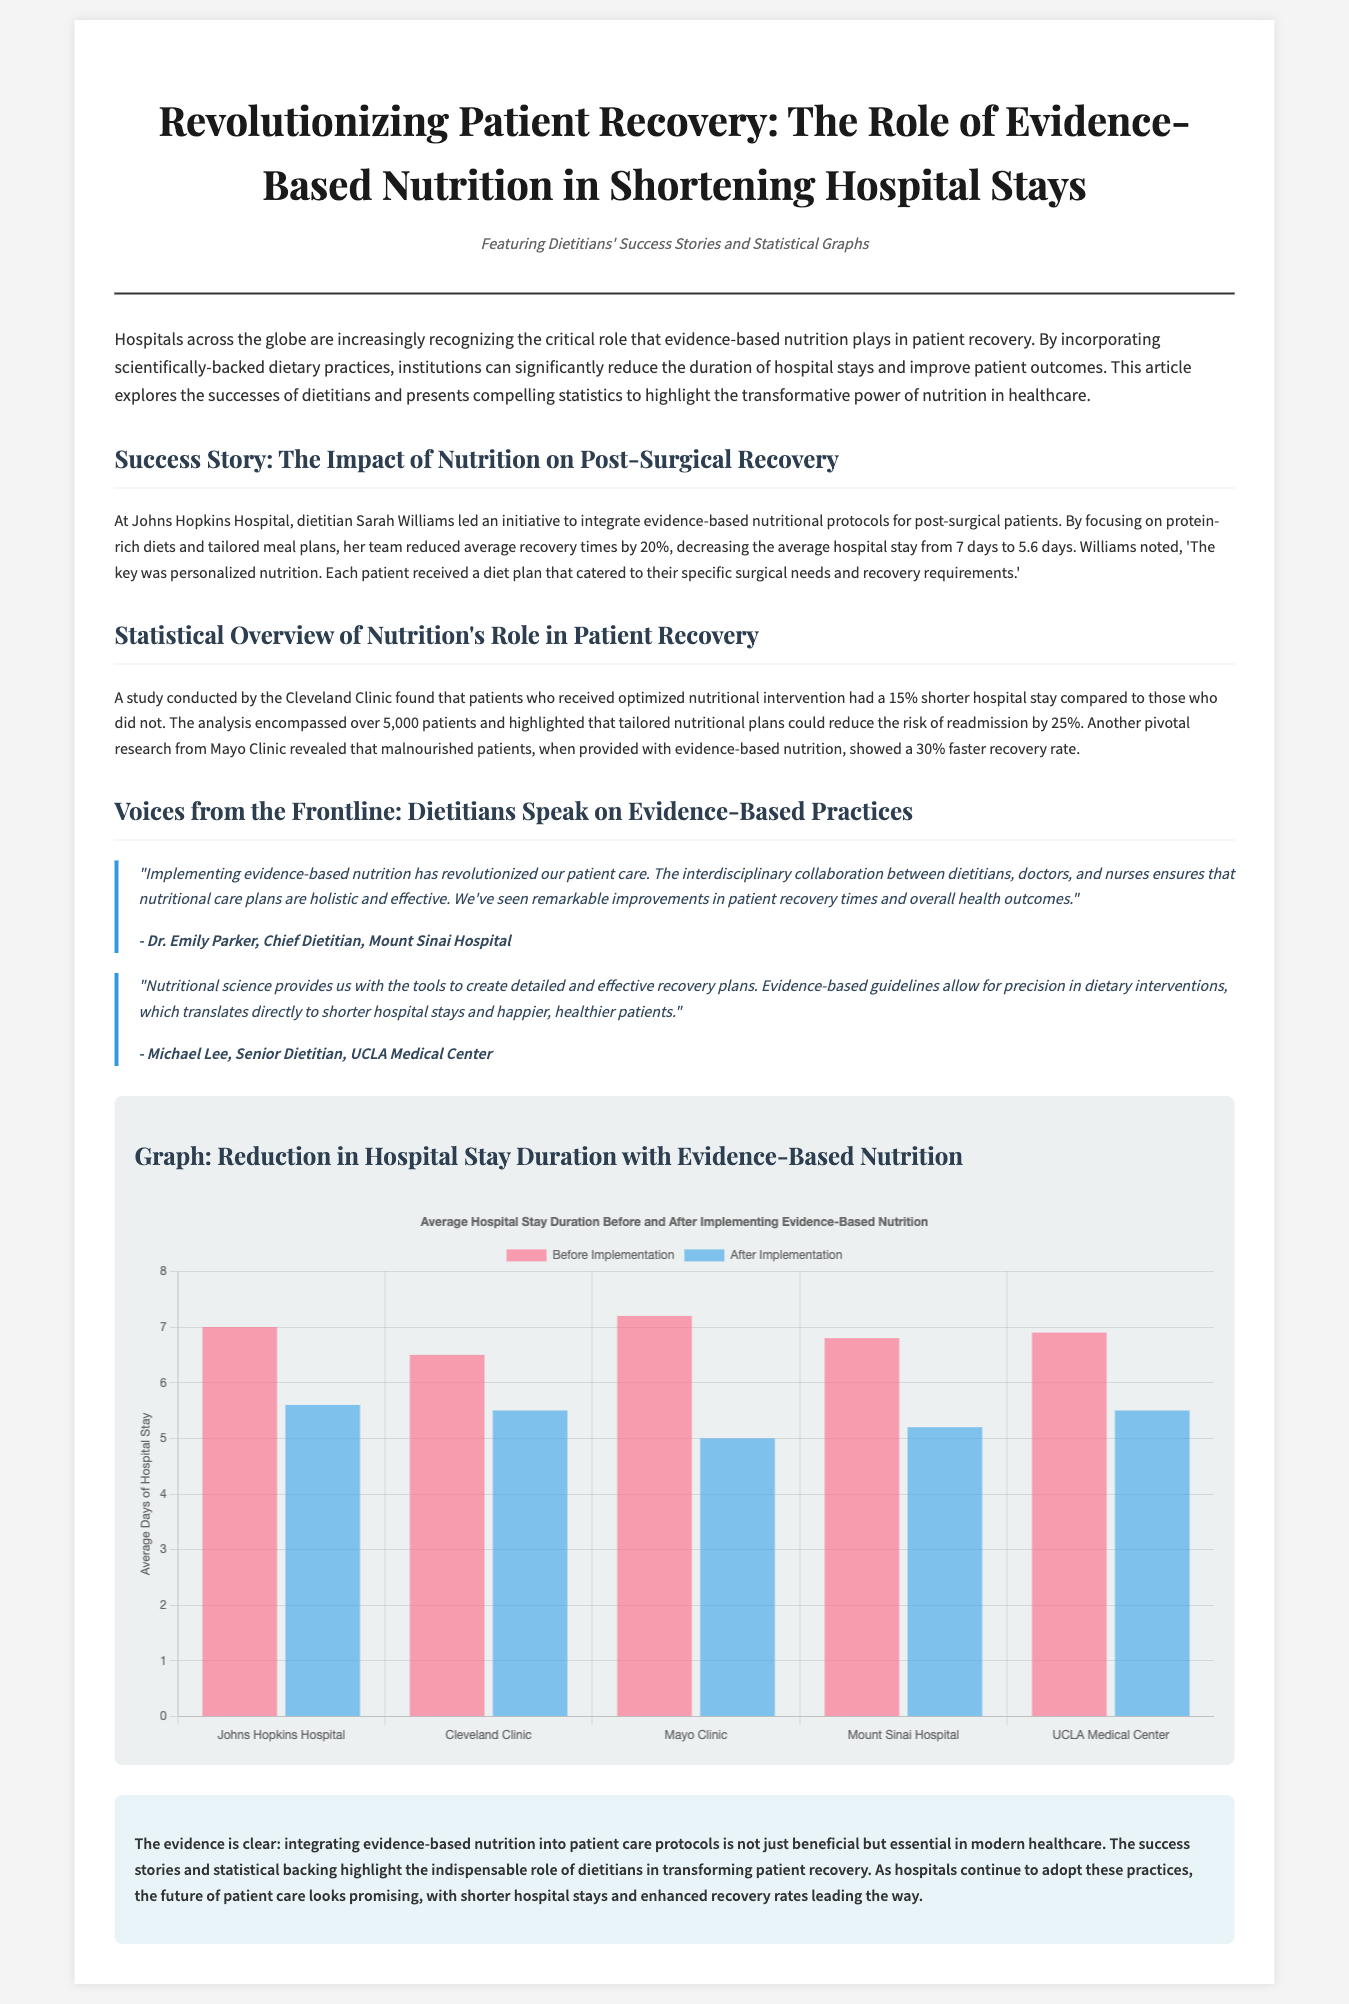What is the title of the article? The title of the article is prominently displayed at the top of the document and is "Revolutionizing Patient Recovery: The Role of Evidence-Based Nutrition in Shortening Hospital Stays".
Answer: Revolutionizing Patient Recovery: The Role of Evidence-Based Nutrition in Shortening Hospital Stays Who led the initiative at Johns Hopkins Hospital? The text specifies that Sarah Williams led the initiative at Johns Hopkins Hospital.
Answer: Sarah Williams What was the average reduction in hospital stay at Johns Hopkins Hospital? The document states the average hospital stay was reduced from 7 days to 5.6 days.
Answer: 1.4 days What percentage shorter was the hospital stay for patients receiving optimized nutritional intervention at Cleveland Clinic? The information indicates that patients had a 15% shorter hospital stay.
Answer: 15% Which hospital reported a 30% faster recovery rate for malnourished patients? The text states that Mayo Clinic reported a 30% faster recovery rate for malnourished patients when provided with evidence-based nutrition.
Answer: Mayo Clinic What is the focus of the statistical overview section? The statistical overview section highlights the role of nutritional interventions in reducing hospital stays and readmission risks based on research studies.
Answer: Role of nutritional interventions How many patients were included in the study by Cleveland Clinic? The document mentions that the analysis encompassed over 5,000 patients.
Answer: 5,000 patients What is the color representing "After Implementation" in the graph? The color representing "After Implementation" in the graph is rgba(54, 162, 235, 0.6).
Answer: rgba(54, 162, 235, 0.6) According to Dr. Emily Parker, what is essential in implementing evidence-based nutrition? The document quotes Dr. Emily Parker stating that interdisciplinary collaboration is essential in implementing evidence-based nutrition.
Answer: Interdisciplinary collaboration 